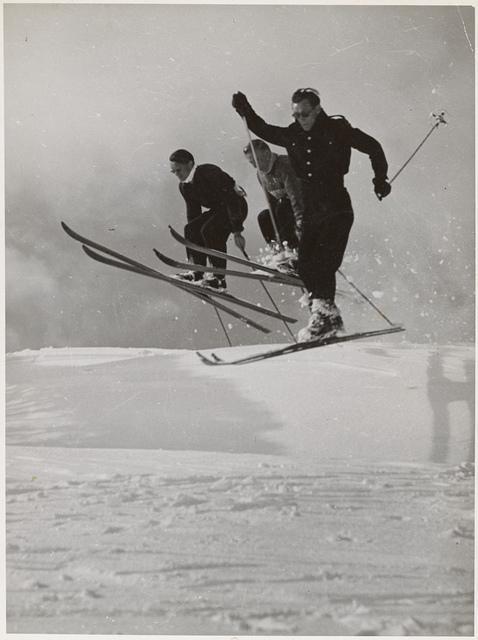How many people are in the photo?
Give a very brief answer. 3. How many slices of pizza are missing from the whole?
Give a very brief answer. 0. 